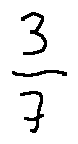Convert formula to latex. <formula><loc_0><loc_0><loc_500><loc_500>\frac { 3 } { 7 }</formula> 